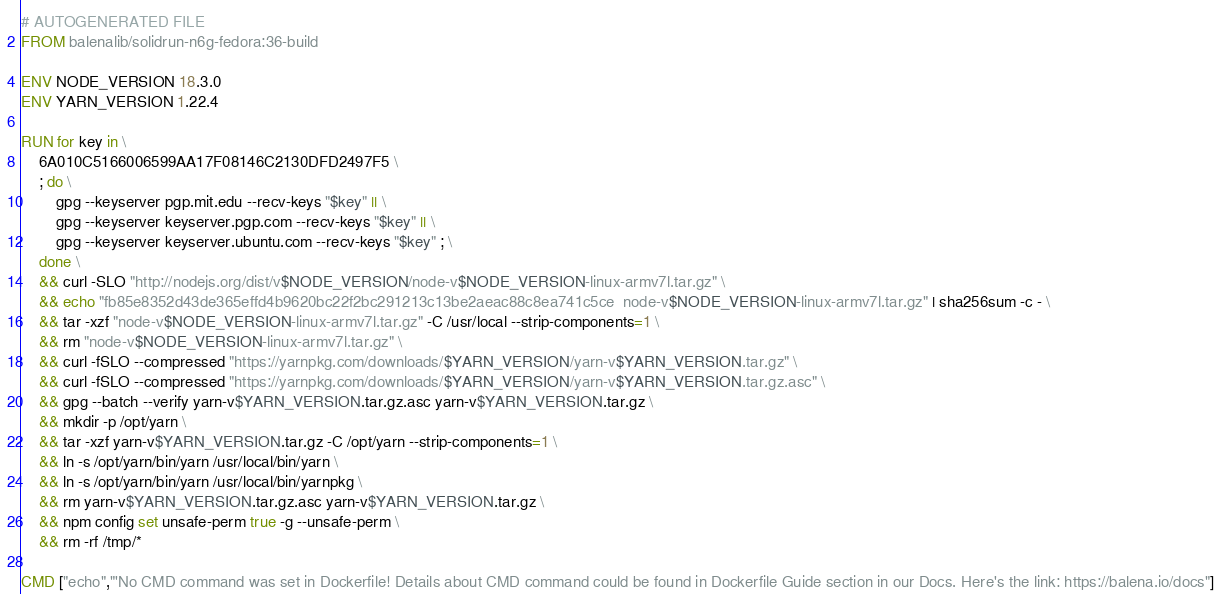<code> <loc_0><loc_0><loc_500><loc_500><_Dockerfile_># AUTOGENERATED FILE
FROM balenalib/solidrun-n6g-fedora:36-build

ENV NODE_VERSION 18.3.0
ENV YARN_VERSION 1.22.4

RUN for key in \
	6A010C5166006599AA17F08146C2130DFD2497F5 \
	; do \
		gpg --keyserver pgp.mit.edu --recv-keys "$key" || \
		gpg --keyserver keyserver.pgp.com --recv-keys "$key" || \
		gpg --keyserver keyserver.ubuntu.com --recv-keys "$key" ; \
	done \
	&& curl -SLO "http://nodejs.org/dist/v$NODE_VERSION/node-v$NODE_VERSION-linux-armv7l.tar.gz" \
	&& echo "fb85e8352d43de365effd4b9620bc22f2bc291213c13be2aeac88c8ea741c5ce  node-v$NODE_VERSION-linux-armv7l.tar.gz" | sha256sum -c - \
	&& tar -xzf "node-v$NODE_VERSION-linux-armv7l.tar.gz" -C /usr/local --strip-components=1 \
	&& rm "node-v$NODE_VERSION-linux-armv7l.tar.gz" \
	&& curl -fSLO --compressed "https://yarnpkg.com/downloads/$YARN_VERSION/yarn-v$YARN_VERSION.tar.gz" \
	&& curl -fSLO --compressed "https://yarnpkg.com/downloads/$YARN_VERSION/yarn-v$YARN_VERSION.tar.gz.asc" \
	&& gpg --batch --verify yarn-v$YARN_VERSION.tar.gz.asc yarn-v$YARN_VERSION.tar.gz \
	&& mkdir -p /opt/yarn \
	&& tar -xzf yarn-v$YARN_VERSION.tar.gz -C /opt/yarn --strip-components=1 \
	&& ln -s /opt/yarn/bin/yarn /usr/local/bin/yarn \
	&& ln -s /opt/yarn/bin/yarn /usr/local/bin/yarnpkg \
	&& rm yarn-v$YARN_VERSION.tar.gz.asc yarn-v$YARN_VERSION.tar.gz \
	&& npm config set unsafe-perm true -g --unsafe-perm \
	&& rm -rf /tmp/*

CMD ["echo","'No CMD command was set in Dockerfile! Details about CMD command could be found in Dockerfile Guide section in our Docs. Here's the link: https://balena.io/docs"]
</code> 